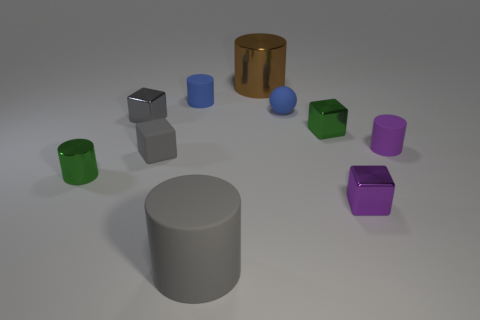Which objects are closest to each other? The two blue cylinders are closest to each other, located towards the center of the image. 